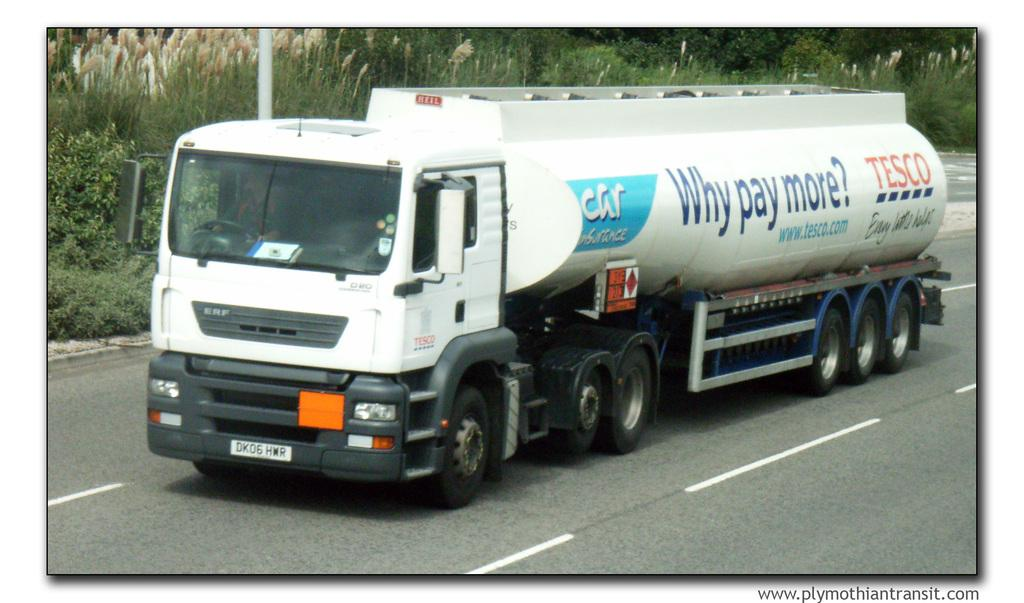What is on the road in the image? There is a truck on the road in the image. What can be seen on the truck? There is writing on the truck. What is visible in the back of the truck? There are plants, trees, and a pole in the back of the truck. Who is inside the truck? A person is sitting in the truck. How many dolls are sitting in the box inside the truck? There is no box or dolls present in the image. 